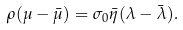<formula> <loc_0><loc_0><loc_500><loc_500>\rho ( \mu - \bar { \mu } ) = \sigma _ { 0 } \bar { \eta } ( \lambda - \bar { \lambda } ) .</formula> 